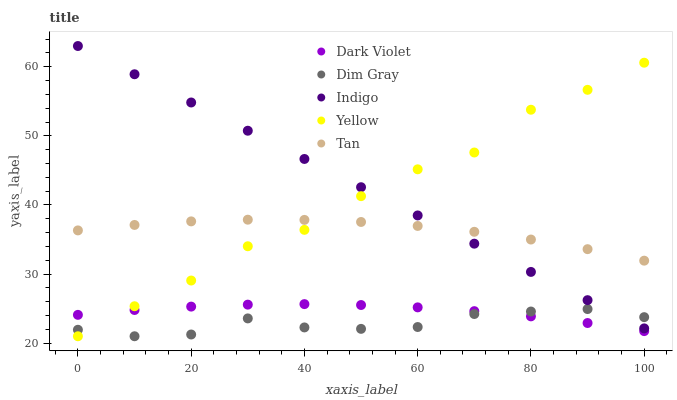Does Dim Gray have the minimum area under the curve?
Answer yes or no. Yes. Does Indigo have the maximum area under the curve?
Answer yes or no. Yes. Does Indigo have the minimum area under the curve?
Answer yes or no. No. Does Dim Gray have the maximum area under the curve?
Answer yes or no. No. Is Indigo the smoothest?
Answer yes or no. Yes. Is Yellow the roughest?
Answer yes or no. Yes. Is Dim Gray the smoothest?
Answer yes or no. No. Is Dim Gray the roughest?
Answer yes or no. No. Does Dim Gray have the lowest value?
Answer yes or no. Yes. Does Indigo have the lowest value?
Answer yes or no. No. Does Indigo have the highest value?
Answer yes or no. Yes. Does Dim Gray have the highest value?
Answer yes or no. No. Is Dark Violet less than Tan?
Answer yes or no. Yes. Is Tan greater than Dark Violet?
Answer yes or no. Yes. Does Dim Gray intersect Indigo?
Answer yes or no. Yes. Is Dim Gray less than Indigo?
Answer yes or no. No. Is Dim Gray greater than Indigo?
Answer yes or no. No. Does Dark Violet intersect Tan?
Answer yes or no. No. 